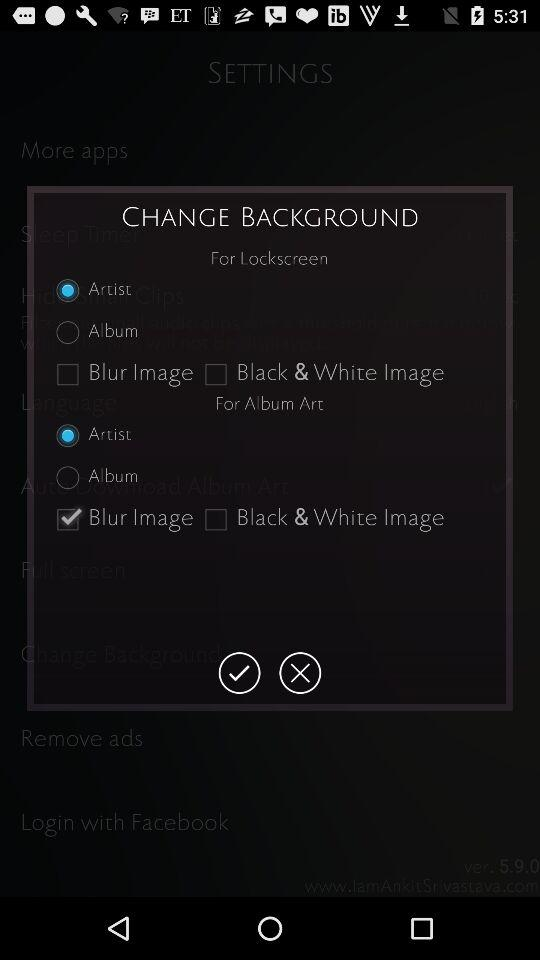What's the status of the "Blur Image" in the album art? The status is "on". 